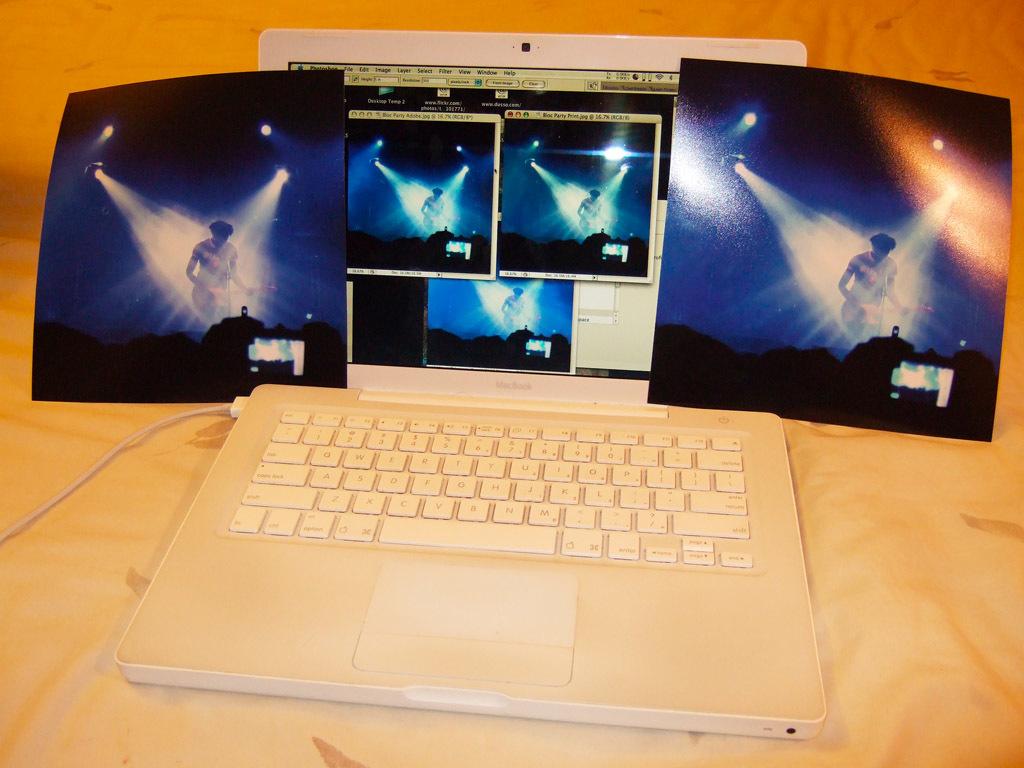What brand of laptop is this?
Your response must be concise. Macbook. 